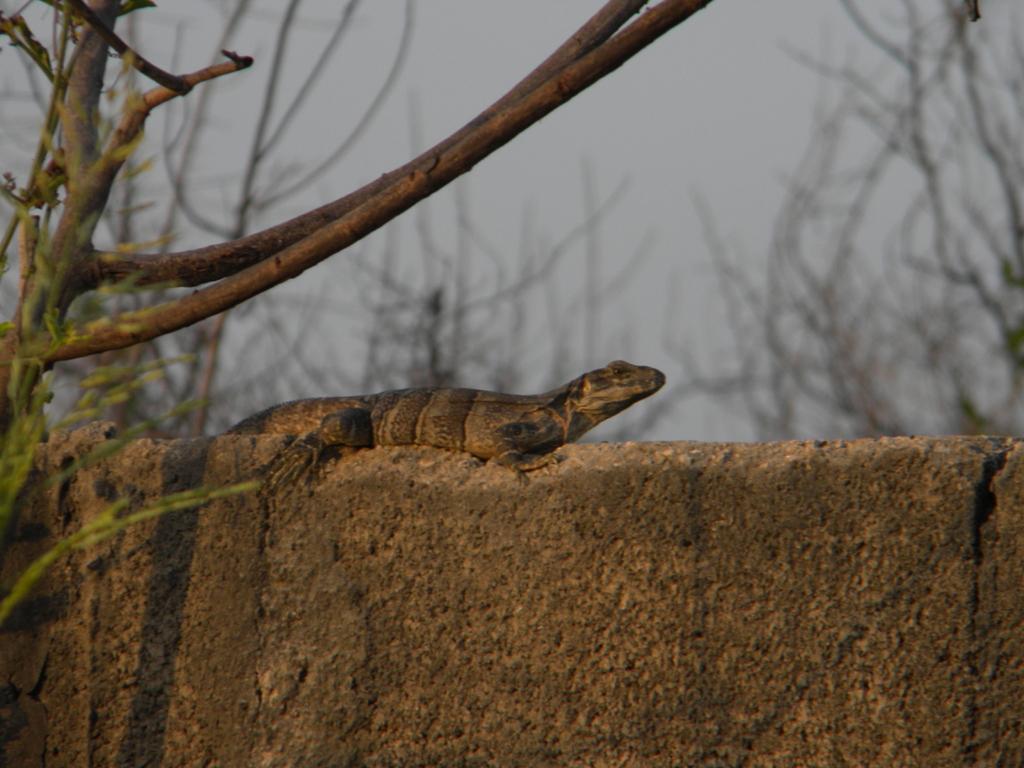Can you describe this image briefly? This picture might be taken from outside of the city. In this image, in the middle, we can see a lizard which is on the wall. On the right side and left side, we can see some trees. In the background, we can see a sky. 